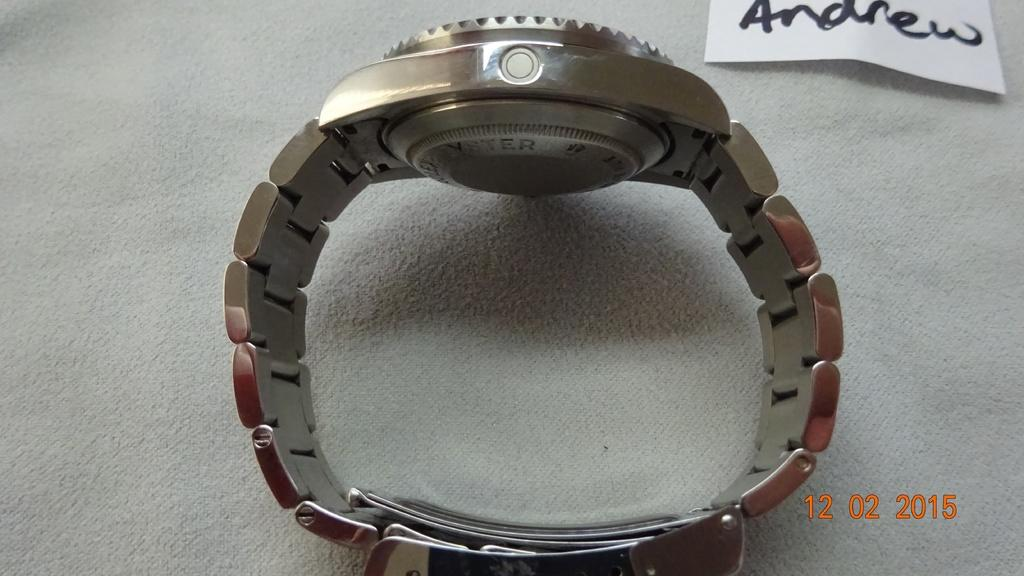Provide a one-sentence caption for the provided image. A metal banded watch on display meant for Andrew. 